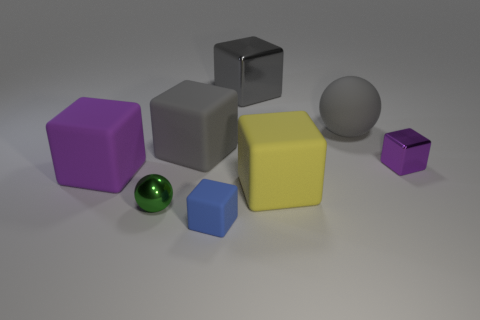There is a matte thing that is both to the left of the small rubber object and on the right side of the metallic sphere; what size is it?
Ensure brevity in your answer.  Large. There is a gray object that is made of the same material as the tiny green object; what is its shape?
Your response must be concise. Cube. What shape is the large yellow thing?
Your response must be concise. Cube. There is a rubber object that is both left of the big gray rubber sphere and behind the purple rubber block; what is its color?
Offer a terse response. Gray. There is a blue rubber object that is the same size as the metal sphere; what shape is it?
Provide a succinct answer. Cube. Are there any large gray rubber objects of the same shape as the large gray metal object?
Offer a very short reply. Yes. There is a blue object that is the same size as the green thing; what material is it?
Make the answer very short. Rubber. What number of large objects are the same color as the large ball?
Offer a terse response. 2. There is a blue cube; does it have the same size as the matte cube that is behind the purple matte block?
Offer a terse response. No. What is the material of the ball that is in front of the tiny cube behind the blue cube?
Provide a succinct answer. Metal. 